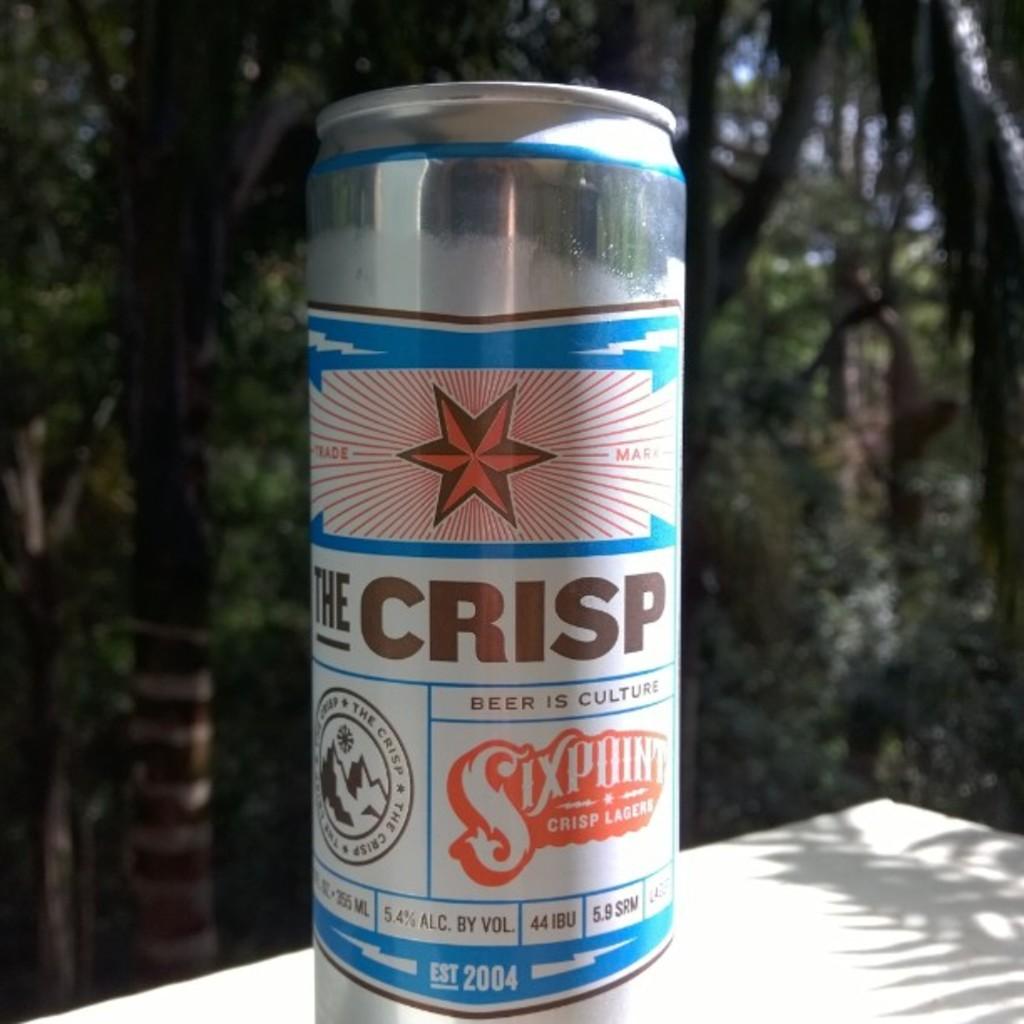What brand of beer is that?
Give a very brief answer. The crisp. When was the beer est?
Provide a short and direct response. 2004. 